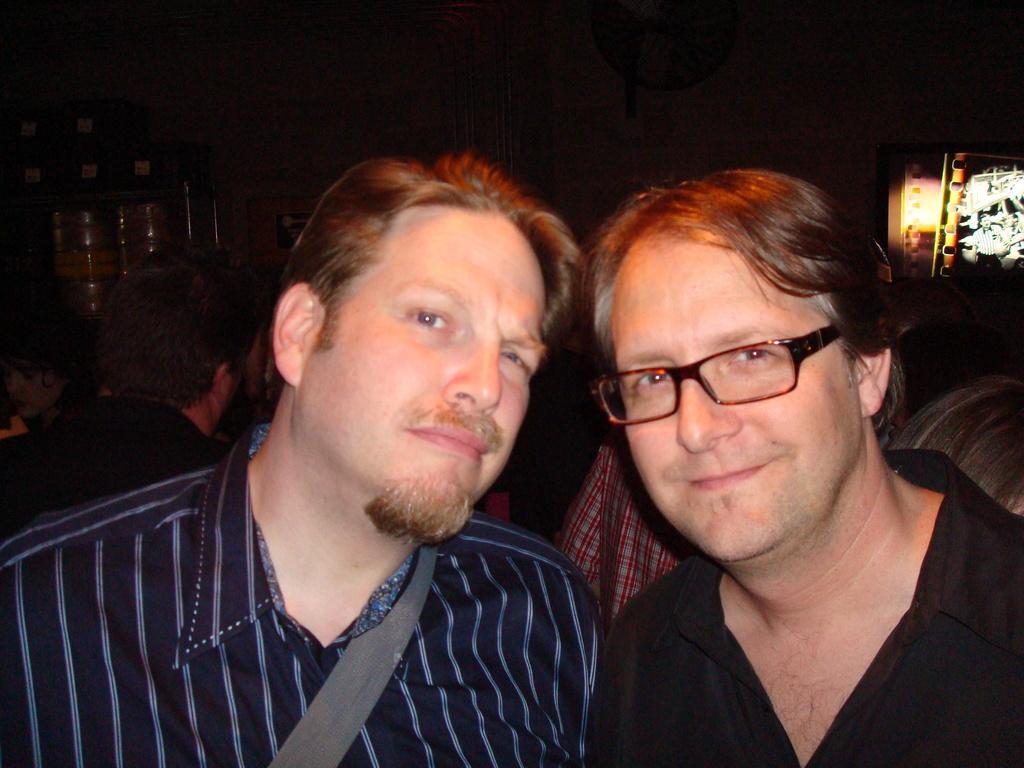Can you describe this image briefly? In this picture we can see two persons, among them one person is wearing spectacles, behind we can see few people. 